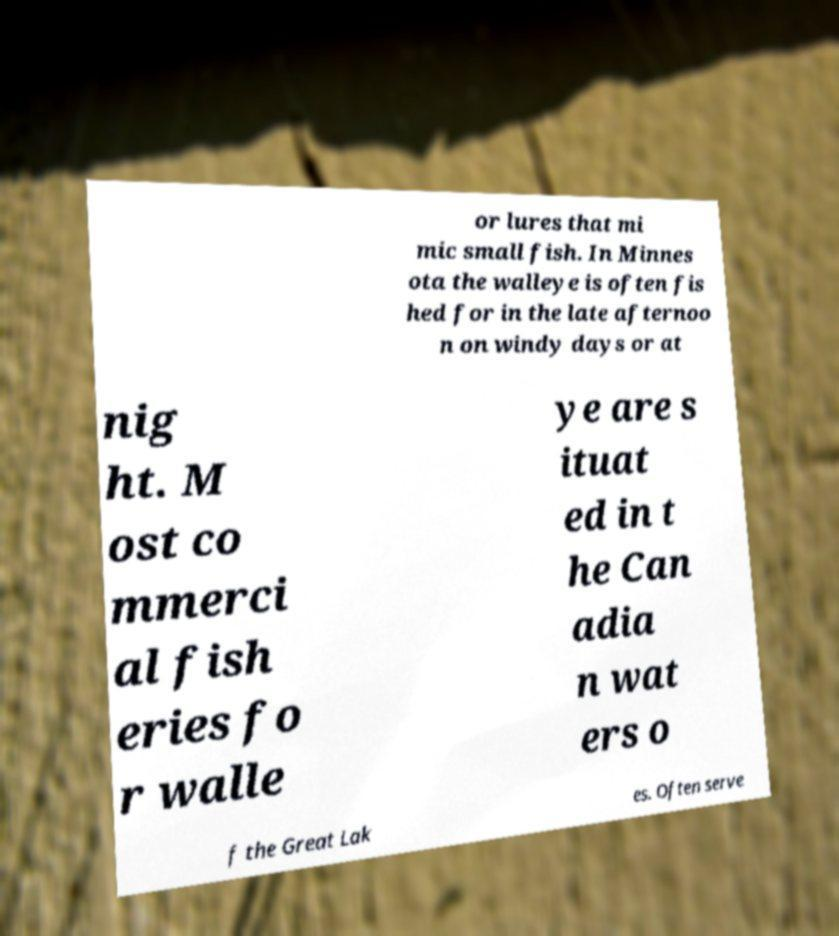Could you assist in decoding the text presented in this image and type it out clearly? or lures that mi mic small fish. In Minnes ota the walleye is often fis hed for in the late afternoo n on windy days or at nig ht. M ost co mmerci al fish eries fo r walle ye are s ituat ed in t he Can adia n wat ers o f the Great Lak es. Often serve 